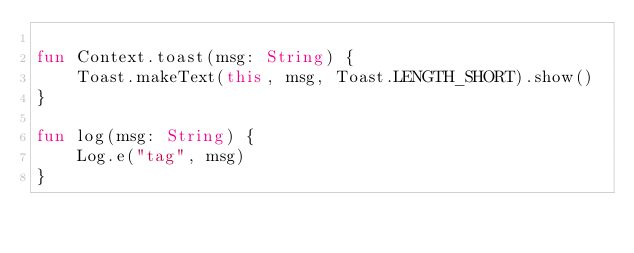<code> <loc_0><loc_0><loc_500><loc_500><_Kotlin_>
fun Context.toast(msg: String) {
    Toast.makeText(this, msg, Toast.LENGTH_SHORT).show()
}

fun log(msg: String) {
    Log.e("tag", msg)
}</code> 